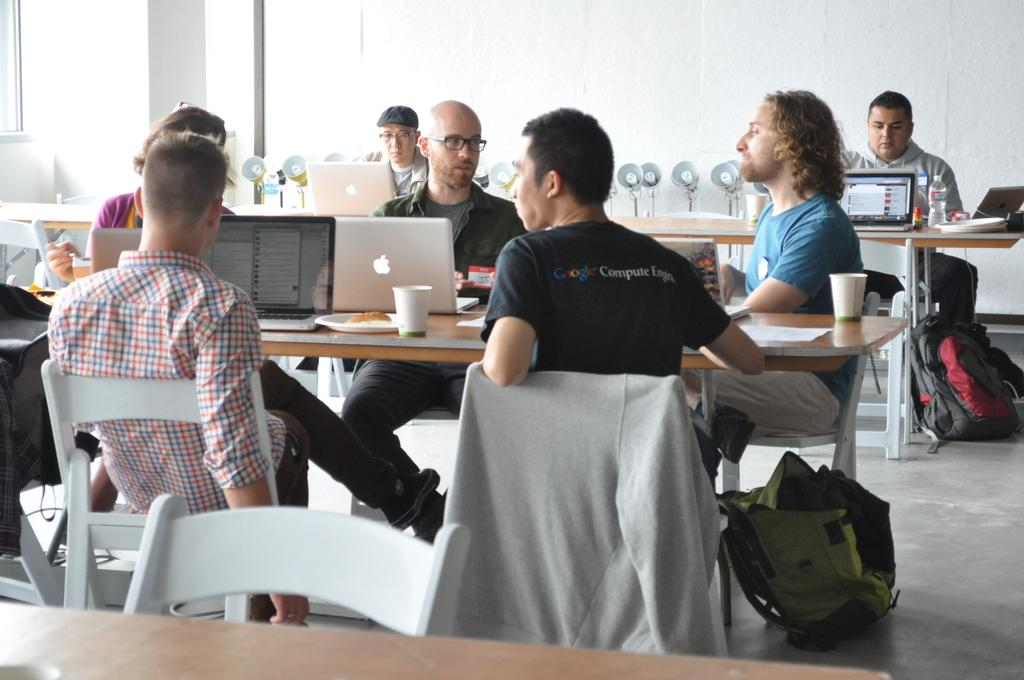<image>
Present a compact description of the photo's key features. A man sitting at a table with several other people wears a shirt which reads Google Computer Engine. 